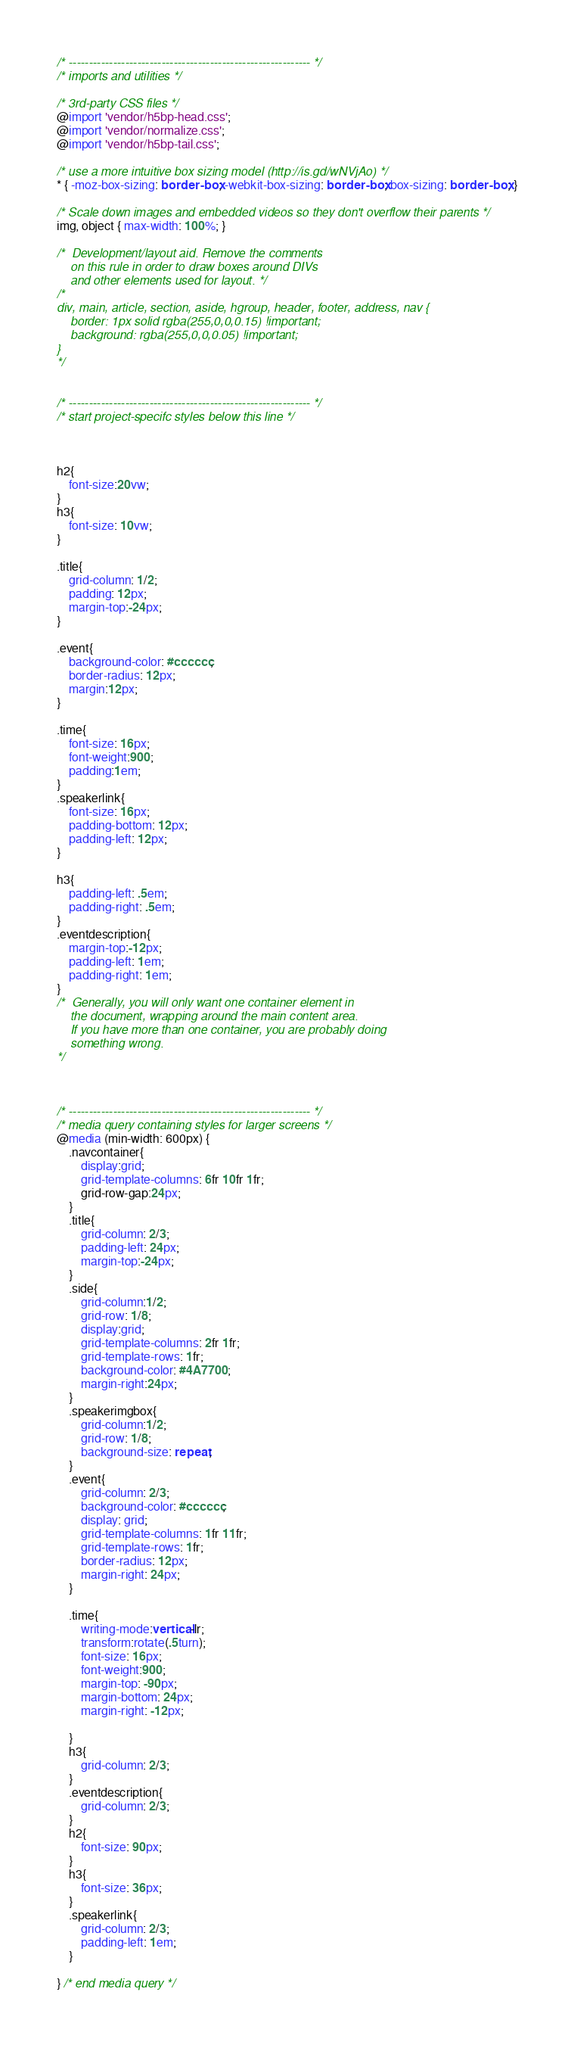Convert code to text. <code><loc_0><loc_0><loc_500><loc_500><_CSS_>/* ------------------------------------------------------------ */
/* imports and utilities */

/* 3rd-party CSS files */
@import 'vendor/h5bp-head.css';
@import 'vendor/normalize.css';
@import 'vendor/h5bp-tail.css';

/* use a more intuitive box sizing model (http://is.gd/wNVjAo) */
* { -moz-box-sizing: border-box; -webkit-box-sizing: border-box; box-sizing: border-box; }

/* Scale down images and embedded videos so they don't overflow their parents */
img, object { max-width: 100%; }

/*	Development/layout aid. Remove the comments
	on this rule in order to draw boxes around DIVs
	and other elements used for layout. */
/*
div, main, article, section, aside, hgroup, header, footer, address, nav {
	border: 1px solid rgba(255,0,0,0.15) !important;
	background: rgba(255,0,0,0.05) !important;
}
*/


/* ------------------------------------------------------------ */
/* start project-specifc styles below this line */



h2{
	font-size:20vw;
}
h3{
	font-size: 10vw;
}

.title{
	grid-column: 1/2;
	padding: 12px;
	margin-top:-24px;
}

.event{
	background-color: #cccccc;
	border-radius: 12px;
	margin:12px;
}

.time{
	font-size: 16px;
	font-weight:900;
	padding:1em;
}
.speakerlink{
	font-size: 16px;
	padding-bottom: 12px;
	padding-left: 12px;
}

h3{
	padding-left: .5em;
	padding-right: .5em;
}
.eventdescription{
	margin-top:-12px;
	padding-left: 1em;
	padding-right: 1em;
}
/*	Generally, you will only want one container element in
	the document, wrapping around the main content area.
	If you have more than one container, you are probably doing
	something wrong.
*/



/* ------------------------------------------------------------ */
/* media query containing styles for larger screens */
@media (min-width: 600px) {
	.navcontainer{
		display:grid;
		grid-template-columns: 6fr 10fr 1fr;
		grid-row-gap:24px;
	}
	.title{
		grid-column: 2/3;
		padding-left: 24px;
		margin-top:-24px;
	}
	.side{
		grid-column:1/2;
		grid-row: 1/8;
		display:grid;
		grid-template-columns: 2fr 1fr;
		grid-template-rows: 1fr;
		background-color: #4A7700;
		margin-right:24px;
	}
	.speakerimgbox{
		grid-column:1/2;
		grid-row: 1/8;
		background-size: repeat;
	}
	.event{
		grid-column: 2/3;
		background-color: #cccccc;
		display: grid;
		grid-template-columns: 1fr 11fr;
		grid-template-rows: 1fr;
		border-radius: 12px;
		margin-right: 24px;
	}

	.time{
		writing-mode:vertical-lr;
		transform:rotate(.5turn);
		font-size: 16px;
		font-weight:900;
		margin-top: -90px;
		margin-bottom: 24px;
		margin-right: -12px;

	}
	h3{
		grid-column: 2/3;
	}
	.eventdescription{
		grid-column: 2/3;
	}
	h2{
		font-size: 90px;
	}
	h3{
		font-size: 36px;
	}
	.speakerlink{
		grid-column: 2/3;
		padding-left: 1em;
	}

} /* end media query */
</code> 